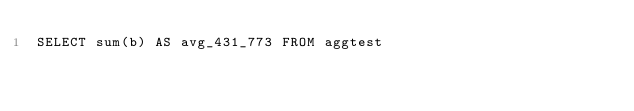Convert code to text. <code><loc_0><loc_0><loc_500><loc_500><_SQL_>SELECT sum(b) AS avg_431_773 FROM aggtest
</code> 